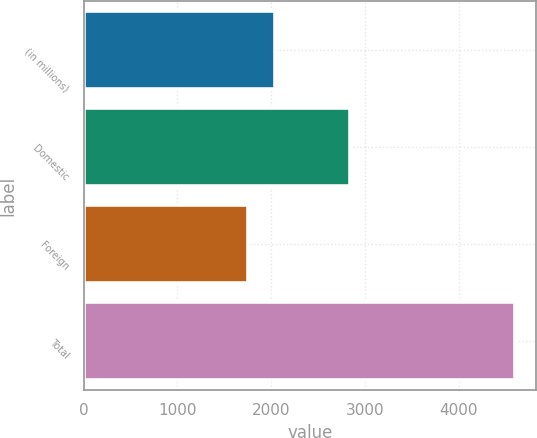<chart> <loc_0><loc_0><loc_500><loc_500><bar_chart><fcel>(in millions)<fcel>Domestic<fcel>Foreign<fcel>Total<nl><fcel>2039<fcel>2840<fcel>1755<fcel>4595<nl></chart> 